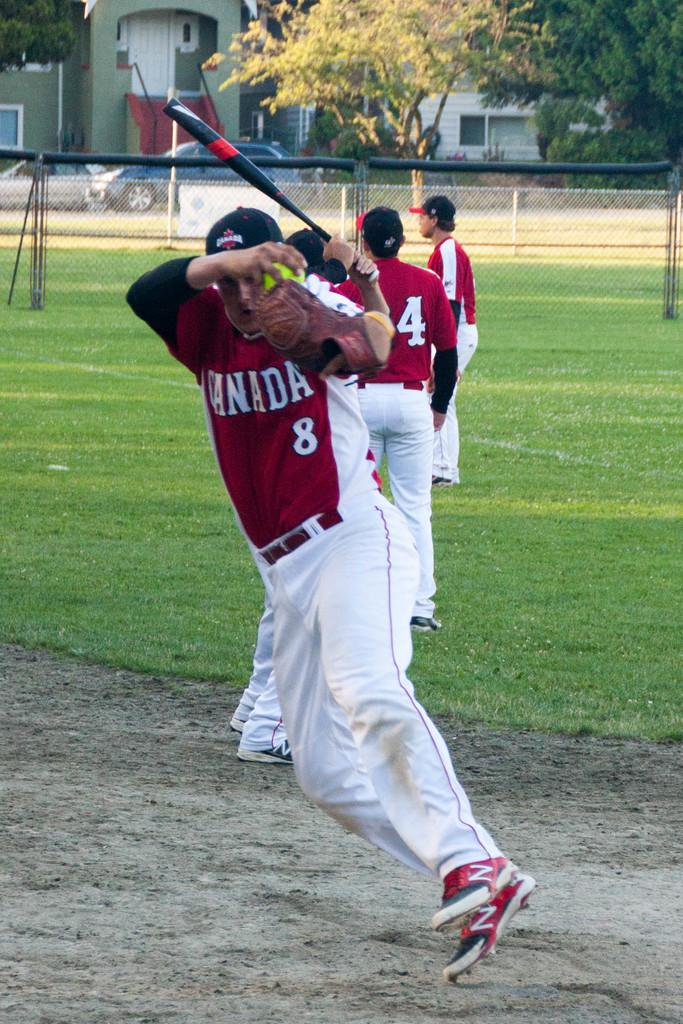<image>
Create a compact narrative representing the image presented. Baseball players from team Canada practicing on the baseball field. 